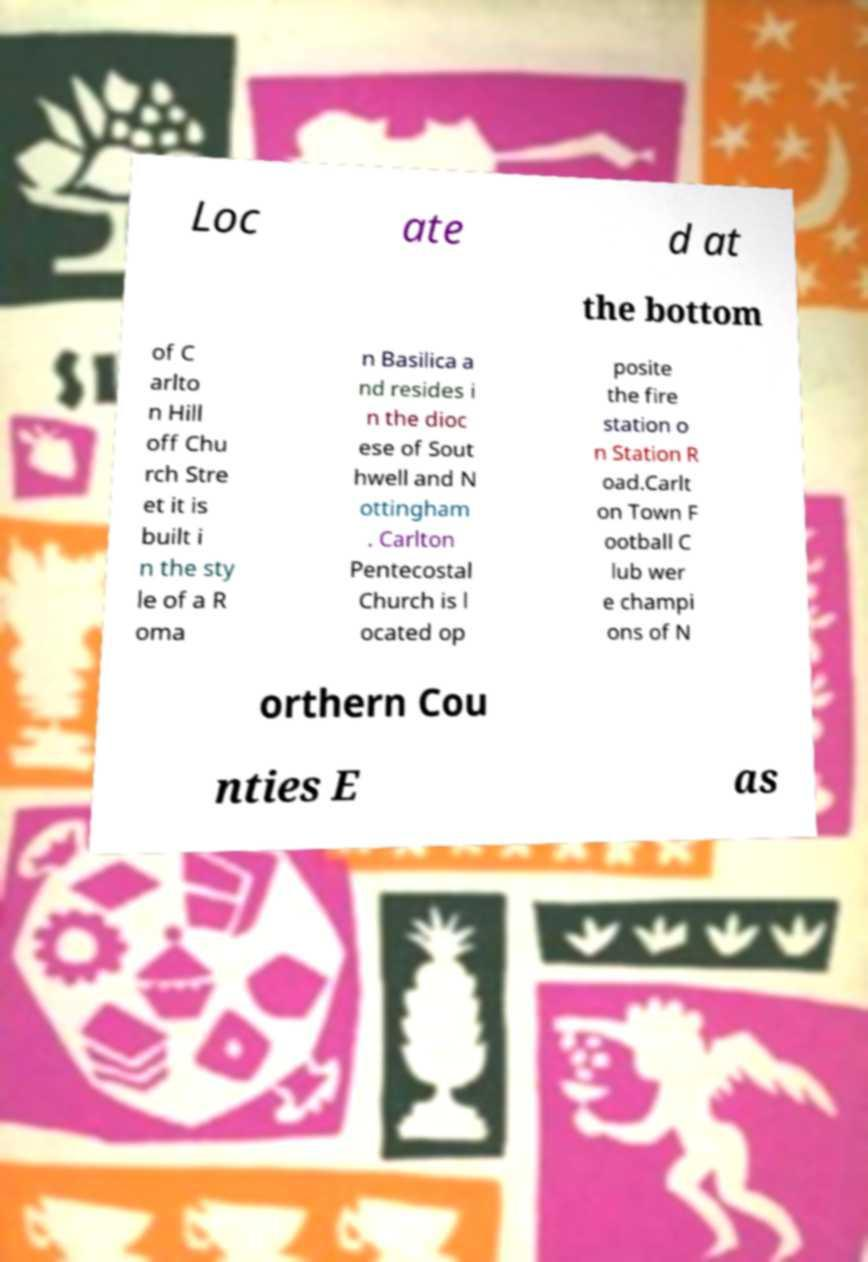Please read and relay the text visible in this image. What does it say? Loc ate d at the bottom of C arlto n Hill off Chu rch Stre et it is built i n the sty le of a R oma n Basilica a nd resides i n the dioc ese of Sout hwell and N ottingham . Carlton Pentecostal Church is l ocated op posite the fire station o n Station R oad.Carlt on Town F ootball C lub wer e champi ons of N orthern Cou nties E as 